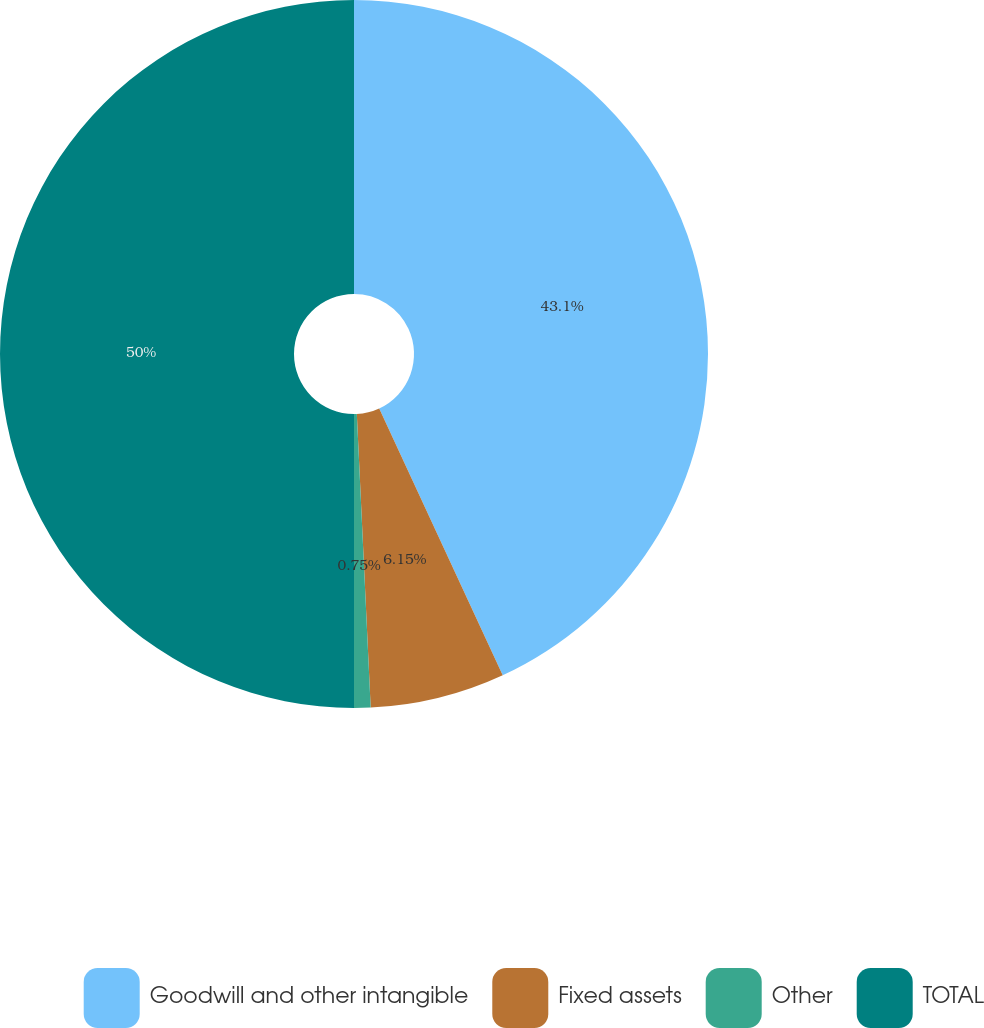Convert chart to OTSL. <chart><loc_0><loc_0><loc_500><loc_500><pie_chart><fcel>Goodwill and other intangible<fcel>Fixed assets<fcel>Other<fcel>TOTAL<nl><fcel>43.1%<fcel>6.15%<fcel>0.75%<fcel>50.0%<nl></chart> 